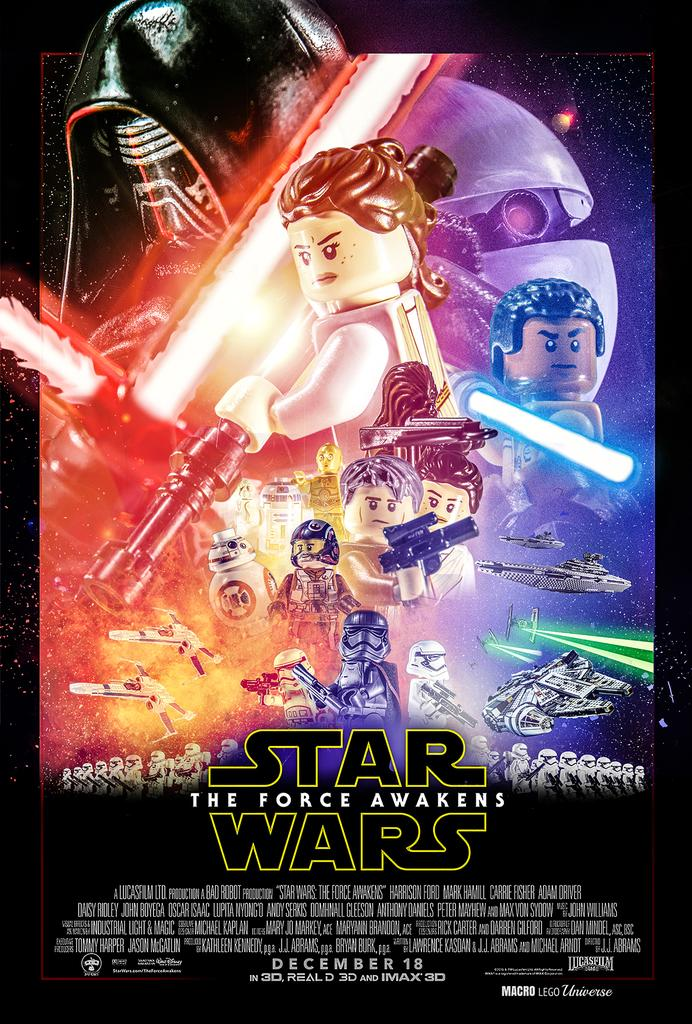Provide a one-sentence caption for the provided image. The Star Wars Force Awakens poster is recreated with LEGO figures. 